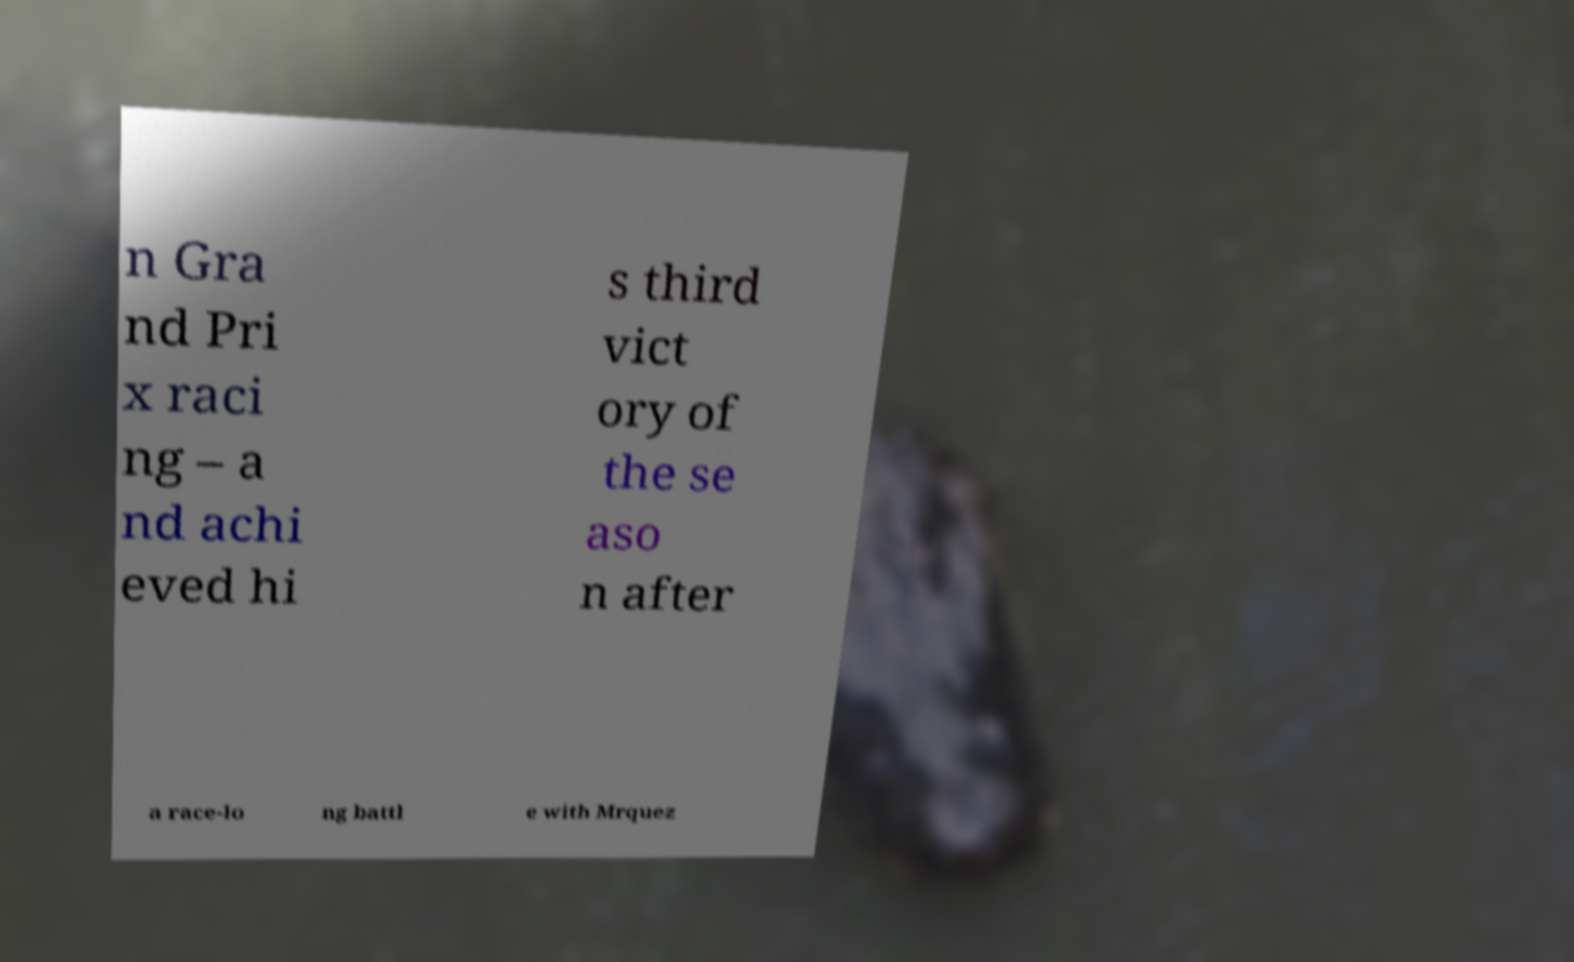Can you read and provide the text displayed in the image?This photo seems to have some interesting text. Can you extract and type it out for me? n Gra nd Pri x raci ng – a nd achi eved hi s third vict ory of the se aso n after a race-lo ng battl e with Mrquez 